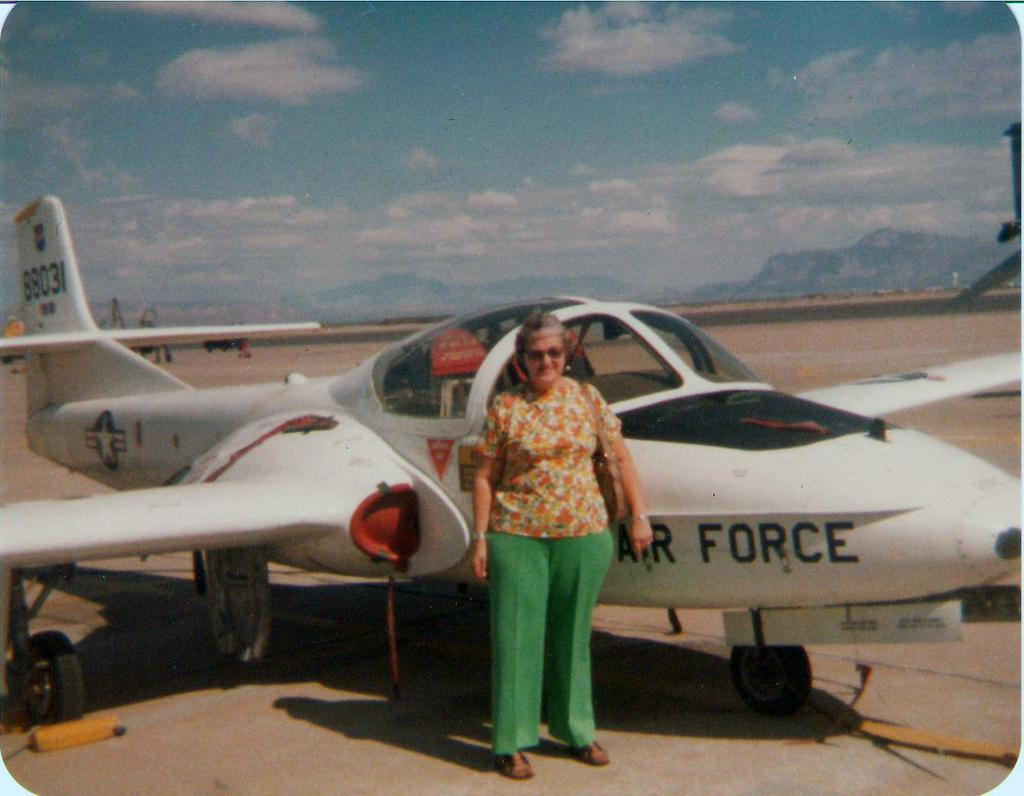Provide a one-sentence caption for the provided image. John's grandmother takes a photo near the Air Force airplane. 